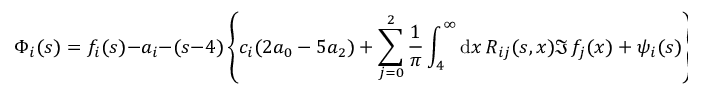Convert formula to latex. <formula><loc_0><loc_0><loc_500><loc_500>\Phi _ { i } ( s ) = f _ { i } ( s ) - a _ { i } - ( s - 4 ) \left \{ c _ { i } ( 2 a _ { 0 } - 5 a _ { 2 } ) + \sum _ { j = 0 } ^ { 2 } { \frac { 1 } { \pi } } \int _ { 4 } ^ { \infty } d x \, R _ { i j } ( s , x ) \Im \, f _ { j } ( x ) + \psi _ { i } ( s ) \right \} .</formula> 